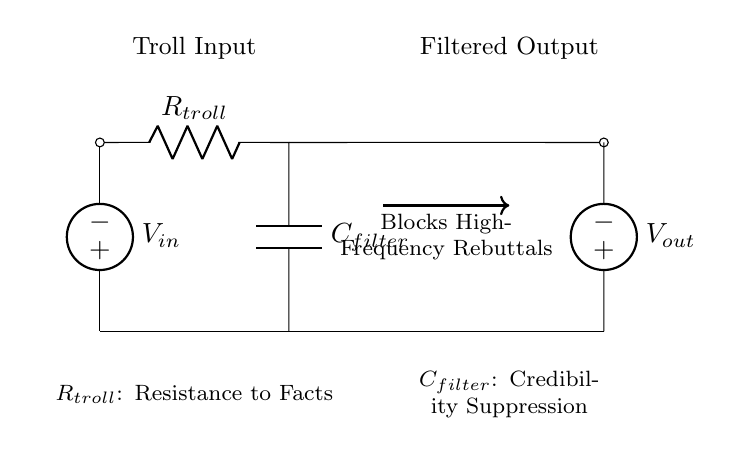What is the input voltage source labeled as? The input voltage source is labeled as \( V_{in} \), indicating the voltage entering the circuit from the troll input.
Answer: V_in What component is represented by \( R_{troll} \)? The component \( R_{troll} \) represents the resistance to facts, which acts to limit the flow of rebuttals within the circuit.
Answer: Resistance to Facts What does the capacitor \( C_{filter} \) do in this circuit? The capacitor \( C_{filter} \) serves to suppress credibility, allowing low-frequency signals to pass while blocking high-frequency signals, like rebuttals.
Answer: Credibility Suppression What is the output voltage source labeled as? The output voltage source is labeled as \( V_{out} \), indicating the voltage that comes out of the filtered circuit after processing the input.
Answer: V_out How is the signal flow indicated in the diagram? The signal flow is indicated by arrows showing the direction from the input source through the resistor and capacitor to the output source, highlighting the filtering process.
Answer: Arrows What type of circuit does this diagram represent? This diagram represents a low-pass filter circuit, which is designed to allow low-frequency signals to pass while blocking higher frequency ones, serving the purpose of filtering rebuttals.
Answer: Low-pass filter 